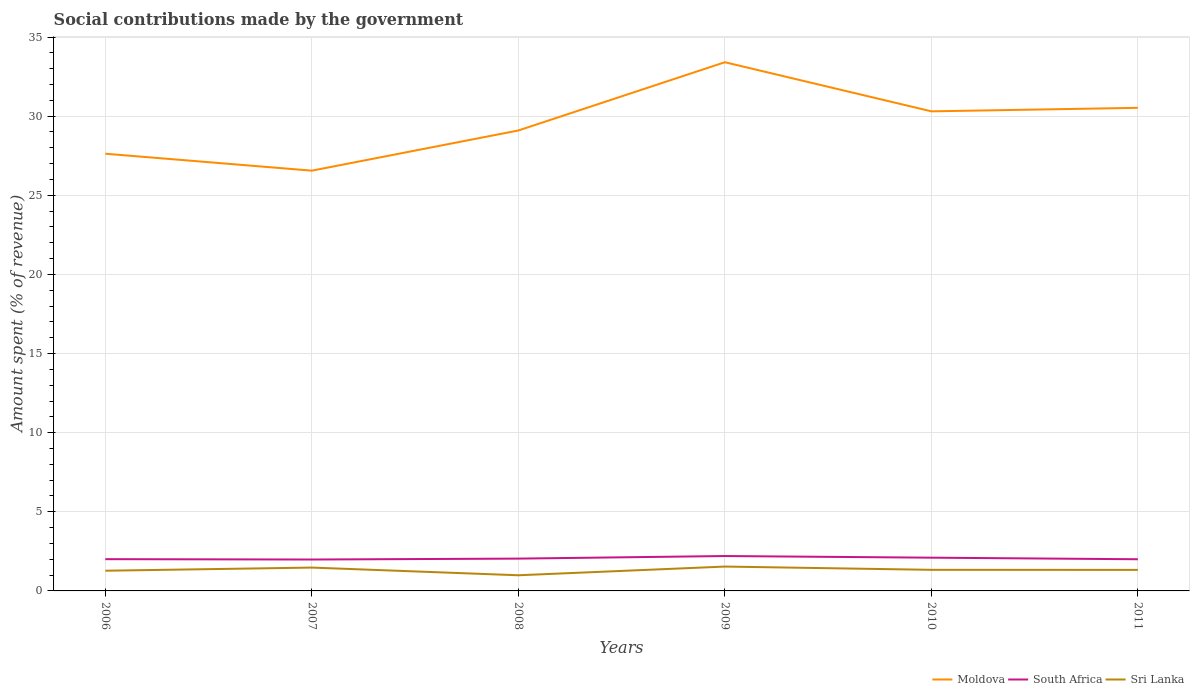Is the number of lines equal to the number of legend labels?
Ensure brevity in your answer.  Yes. Across all years, what is the maximum amount spent (in %) on social contributions in Moldova?
Give a very brief answer. 26.56. In which year was the amount spent (in %) on social contributions in Moldova maximum?
Provide a short and direct response. 2007. What is the total amount spent (in %) on social contributions in South Africa in the graph?
Offer a terse response. -0.06. What is the difference between the highest and the second highest amount spent (in %) on social contributions in Sri Lanka?
Give a very brief answer. 0.55. Is the amount spent (in %) on social contributions in Moldova strictly greater than the amount spent (in %) on social contributions in Sri Lanka over the years?
Provide a short and direct response. No. How many lines are there?
Provide a short and direct response. 3. Does the graph contain grids?
Your response must be concise. Yes. Where does the legend appear in the graph?
Offer a very short reply. Bottom right. How many legend labels are there?
Keep it short and to the point. 3. What is the title of the graph?
Provide a short and direct response. Social contributions made by the government. Does "Myanmar" appear as one of the legend labels in the graph?
Ensure brevity in your answer.  No. What is the label or title of the X-axis?
Your response must be concise. Years. What is the label or title of the Y-axis?
Offer a very short reply. Amount spent (% of revenue). What is the Amount spent (% of revenue) of Moldova in 2006?
Ensure brevity in your answer.  27.63. What is the Amount spent (% of revenue) of South Africa in 2006?
Your response must be concise. 2.01. What is the Amount spent (% of revenue) of Sri Lanka in 2006?
Offer a very short reply. 1.28. What is the Amount spent (% of revenue) in Moldova in 2007?
Your answer should be very brief. 26.56. What is the Amount spent (% of revenue) of South Africa in 2007?
Make the answer very short. 1.98. What is the Amount spent (% of revenue) in Sri Lanka in 2007?
Your response must be concise. 1.48. What is the Amount spent (% of revenue) of Moldova in 2008?
Offer a terse response. 29.1. What is the Amount spent (% of revenue) in South Africa in 2008?
Your answer should be very brief. 2.04. What is the Amount spent (% of revenue) of Sri Lanka in 2008?
Offer a very short reply. 0.99. What is the Amount spent (% of revenue) of Moldova in 2009?
Your response must be concise. 33.41. What is the Amount spent (% of revenue) of South Africa in 2009?
Your answer should be compact. 2.2. What is the Amount spent (% of revenue) of Sri Lanka in 2009?
Provide a short and direct response. 1.54. What is the Amount spent (% of revenue) of Moldova in 2010?
Your response must be concise. 30.31. What is the Amount spent (% of revenue) in South Africa in 2010?
Offer a terse response. 2.1. What is the Amount spent (% of revenue) in Sri Lanka in 2010?
Your answer should be compact. 1.33. What is the Amount spent (% of revenue) in Moldova in 2011?
Ensure brevity in your answer.  30.53. What is the Amount spent (% of revenue) in South Africa in 2011?
Provide a succinct answer. 2. What is the Amount spent (% of revenue) in Sri Lanka in 2011?
Offer a terse response. 1.33. Across all years, what is the maximum Amount spent (% of revenue) in Moldova?
Keep it short and to the point. 33.41. Across all years, what is the maximum Amount spent (% of revenue) of South Africa?
Your answer should be compact. 2.2. Across all years, what is the maximum Amount spent (% of revenue) in Sri Lanka?
Keep it short and to the point. 1.54. Across all years, what is the minimum Amount spent (% of revenue) of Moldova?
Your response must be concise. 26.56. Across all years, what is the minimum Amount spent (% of revenue) of South Africa?
Ensure brevity in your answer.  1.98. Across all years, what is the minimum Amount spent (% of revenue) in Sri Lanka?
Provide a succinct answer. 0.99. What is the total Amount spent (% of revenue) of Moldova in the graph?
Give a very brief answer. 177.52. What is the total Amount spent (% of revenue) in South Africa in the graph?
Give a very brief answer. 12.34. What is the total Amount spent (% of revenue) of Sri Lanka in the graph?
Provide a short and direct response. 7.94. What is the difference between the Amount spent (% of revenue) in Moldova in 2006 and that in 2007?
Your answer should be very brief. 1.07. What is the difference between the Amount spent (% of revenue) in South Africa in 2006 and that in 2007?
Your answer should be very brief. 0.02. What is the difference between the Amount spent (% of revenue) of Sri Lanka in 2006 and that in 2007?
Provide a short and direct response. -0.2. What is the difference between the Amount spent (% of revenue) of Moldova in 2006 and that in 2008?
Offer a very short reply. -1.47. What is the difference between the Amount spent (% of revenue) in South Africa in 2006 and that in 2008?
Offer a very short reply. -0.03. What is the difference between the Amount spent (% of revenue) of Sri Lanka in 2006 and that in 2008?
Your response must be concise. 0.29. What is the difference between the Amount spent (% of revenue) in Moldova in 2006 and that in 2009?
Offer a terse response. -5.78. What is the difference between the Amount spent (% of revenue) in South Africa in 2006 and that in 2009?
Ensure brevity in your answer.  -0.2. What is the difference between the Amount spent (% of revenue) in Sri Lanka in 2006 and that in 2009?
Offer a terse response. -0.26. What is the difference between the Amount spent (% of revenue) of Moldova in 2006 and that in 2010?
Your response must be concise. -2.68. What is the difference between the Amount spent (% of revenue) in South Africa in 2006 and that in 2010?
Give a very brief answer. -0.09. What is the difference between the Amount spent (% of revenue) in Sri Lanka in 2006 and that in 2010?
Offer a very short reply. -0.06. What is the difference between the Amount spent (% of revenue) of Moldova in 2006 and that in 2011?
Offer a very short reply. -2.9. What is the difference between the Amount spent (% of revenue) of South Africa in 2006 and that in 2011?
Your response must be concise. 0.01. What is the difference between the Amount spent (% of revenue) of Sri Lanka in 2006 and that in 2011?
Provide a succinct answer. -0.05. What is the difference between the Amount spent (% of revenue) of Moldova in 2007 and that in 2008?
Give a very brief answer. -2.54. What is the difference between the Amount spent (% of revenue) in South Africa in 2007 and that in 2008?
Ensure brevity in your answer.  -0.06. What is the difference between the Amount spent (% of revenue) in Sri Lanka in 2007 and that in 2008?
Provide a succinct answer. 0.49. What is the difference between the Amount spent (% of revenue) in Moldova in 2007 and that in 2009?
Provide a short and direct response. -6.85. What is the difference between the Amount spent (% of revenue) of South Africa in 2007 and that in 2009?
Offer a terse response. -0.22. What is the difference between the Amount spent (% of revenue) of Sri Lanka in 2007 and that in 2009?
Give a very brief answer. -0.06. What is the difference between the Amount spent (% of revenue) in Moldova in 2007 and that in 2010?
Give a very brief answer. -3.75. What is the difference between the Amount spent (% of revenue) in South Africa in 2007 and that in 2010?
Your answer should be compact. -0.12. What is the difference between the Amount spent (% of revenue) of Sri Lanka in 2007 and that in 2010?
Provide a succinct answer. 0.14. What is the difference between the Amount spent (% of revenue) of Moldova in 2007 and that in 2011?
Make the answer very short. -3.97. What is the difference between the Amount spent (% of revenue) of South Africa in 2007 and that in 2011?
Your response must be concise. -0.02. What is the difference between the Amount spent (% of revenue) of Sri Lanka in 2007 and that in 2011?
Offer a very short reply. 0.15. What is the difference between the Amount spent (% of revenue) in Moldova in 2008 and that in 2009?
Your answer should be very brief. -4.31. What is the difference between the Amount spent (% of revenue) in South Africa in 2008 and that in 2009?
Your response must be concise. -0.16. What is the difference between the Amount spent (% of revenue) in Sri Lanka in 2008 and that in 2009?
Make the answer very short. -0.55. What is the difference between the Amount spent (% of revenue) in Moldova in 2008 and that in 2010?
Your answer should be very brief. -1.21. What is the difference between the Amount spent (% of revenue) in South Africa in 2008 and that in 2010?
Your answer should be compact. -0.06. What is the difference between the Amount spent (% of revenue) in Sri Lanka in 2008 and that in 2010?
Your response must be concise. -0.34. What is the difference between the Amount spent (% of revenue) of Moldova in 2008 and that in 2011?
Provide a short and direct response. -1.43. What is the difference between the Amount spent (% of revenue) of South Africa in 2008 and that in 2011?
Your response must be concise. 0.04. What is the difference between the Amount spent (% of revenue) of Sri Lanka in 2008 and that in 2011?
Offer a terse response. -0.34. What is the difference between the Amount spent (% of revenue) of Moldova in 2009 and that in 2010?
Offer a terse response. 3.1. What is the difference between the Amount spent (% of revenue) of South Africa in 2009 and that in 2010?
Provide a short and direct response. 0.1. What is the difference between the Amount spent (% of revenue) of Sri Lanka in 2009 and that in 2010?
Provide a short and direct response. 0.21. What is the difference between the Amount spent (% of revenue) in Moldova in 2009 and that in 2011?
Your answer should be compact. 2.88. What is the difference between the Amount spent (% of revenue) of South Africa in 2009 and that in 2011?
Give a very brief answer. 0.2. What is the difference between the Amount spent (% of revenue) in Sri Lanka in 2009 and that in 2011?
Offer a terse response. 0.21. What is the difference between the Amount spent (% of revenue) of Moldova in 2010 and that in 2011?
Make the answer very short. -0.22. What is the difference between the Amount spent (% of revenue) of South Africa in 2010 and that in 2011?
Offer a very short reply. 0.1. What is the difference between the Amount spent (% of revenue) of Sri Lanka in 2010 and that in 2011?
Provide a short and direct response. 0. What is the difference between the Amount spent (% of revenue) of Moldova in 2006 and the Amount spent (% of revenue) of South Africa in 2007?
Give a very brief answer. 25.64. What is the difference between the Amount spent (% of revenue) of Moldova in 2006 and the Amount spent (% of revenue) of Sri Lanka in 2007?
Offer a very short reply. 26.15. What is the difference between the Amount spent (% of revenue) in South Africa in 2006 and the Amount spent (% of revenue) in Sri Lanka in 2007?
Your response must be concise. 0.53. What is the difference between the Amount spent (% of revenue) of Moldova in 2006 and the Amount spent (% of revenue) of South Africa in 2008?
Your answer should be compact. 25.59. What is the difference between the Amount spent (% of revenue) in Moldova in 2006 and the Amount spent (% of revenue) in Sri Lanka in 2008?
Offer a very short reply. 26.64. What is the difference between the Amount spent (% of revenue) of South Africa in 2006 and the Amount spent (% of revenue) of Sri Lanka in 2008?
Give a very brief answer. 1.02. What is the difference between the Amount spent (% of revenue) in Moldova in 2006 and the Amount spent (% of revenue) in South Africa in 2009?
Your response must be concise. 25.42. What is the difference between the Amount spent (% of revenue) of Moldova in 2006 and the Amount spent (% of revenue) of Sri Lanka in 2009?
Your response must be concise. 26.09. What is the difference between the Amount spent (% of revenue) in South Africa in 2006 and the Amount spent (% of revenue) in Sri Lanka in 2009?
Provide a succinct answer. 0.47. What is the difference between the Amount spent (% of revenue) of Moldova in 2006 and the Amount spent (% of revenue) of South Africa in 2010?
Make the answer very short. 25.53. What is the difference between the Amount spent (% of revenue) of Moldova in 2006 and the Amount spent (% of revenue) of Sri Lanka in 2010?
Your answer should be compact. 26.29. What is the difference between the Amount spent (% of revenue) in South Africa in 2006 and the Amount spent (% of revenue) in Sri Lanka in 2010?
Offer a very short reply. 0.67. What is the difference between the Amount spent (% of revenue) in Moldova in 2006 and the Amount spent (% of revenue) in South Africa in 2011?
Your response must be concise. 25.63. What is the difference between the Amount spent (% of revenue) in Moldova in 2006 and the Amount spent (% of revenue) in Sri Lanka in 2011?
Your response must be concise. 26.3. What is the difference between the Amount spent (% of revenue) of South Africa in 2006 and the Amount spent (% of revenue) of Sri Lanka in 2011?
Make the answer very short. 0.68. What is the difference between the Amount spent (% of revenue) in Moldova in 2007 and the Amount spent (% of revenue) in South Africa in 2008?
Your answer should be compact. 24.52. What is the difference between the Amount spent (% of revenue) in Moldova in 2007 and the Amount spent (% of revenue) in Sri Lanka in 2008?
Offer a very short reply. 25.57. What is the difference between the Amount spent (% of revenue) of Moldova in 2007 and the Amount spent (% of revenue) of South Africa in 2009?
Your answer should be compact. 24.35. What is the difference between the Amount spent (% of revenue) in Moldova in 2007 and the Amount spent (% of revenue) in Sri Lanka in 2009?
Your answer should be very brief. 25.02. What is the difference between the Amount spent (% of revenue) of South Africa in 2007 and the Amount spent (% of revenue) of Sri Lanka in 2009?
Your answer should be very brief. 0.45. What is the difference between the Amount spent (% of revenue) of Moldova in 2007 and the Amount spent (% of revenue) of South Africa in 2010?
Your answer should be compact. 24.46. What is the difference between the Amount spent (% of revenue) in Moldova in 2007 and the Amount spent (% of revenue) in Sri Lanka in 2010?
Your response must be concise. 25.22. What is the difference between the Amount spent (% of revenue) in South Africa in 2007 and the Amount spent (% of revenue) in Sri Lanka in 2010?
Provide a short and direct response. 0.65. What is the difference between the Amount spent (% of revenue) of Moldova in 2007 and the Amount spent (% of revenue) of South Africa in 2011?
Ensure brevity in your answer.  24.56. What is the difference between the Amount spent (% of revenue) of Moldova in 2007 and the Amount spent (% of revenue) of Sri Lanka in 2011?
Give a very brief answer. 25.23. What is the difference between the Amount spent (% of revenue) in South Africa in 2007 and the Amount spent (% of revenue) in Sri Lanka in 2011?
Make the answer very short. 0.66. What is the difference between the Amount spent (% of revenue) of Moldova in 2008 and the Amount spent (% of revenue) of South Africa in 2009?
Give a very brief answer. 26.89. What is the difference between the Amount spent (% of revenue) of Moldova in 2008 and the Amount spent (% of revenue) of Sri Lanka in 2009?
Make the answer very short. 27.56. What is the difference between the Amount spent (% of revenue) in South Africa in 2008 and the Amount spent (% of revenue) in Sri Lanka in 2009?
Your answer should be compact. 0.5. What is the difference between the Amount spent (% of revenue) of Moldova in 2008 and the Amount spent (% of revenue) of South Africa in 2010?
Your answer should be compact. 26.99. What is the difference between the Amount spent (% of revenue) in Moldova in 2008 and the Amount spent (% of revenue) in Sri Lanka in 2010?
Provide a short and direct response. 27.76. What is the difference between the Amount spent (% of revenue) in South Africa in 2008 and the Amount spent (% of revenue) in Sri Lanka in 2010?
Provide a short and direct response. 0.71. What is the difference between the Amount spent (% of revenue) of Moldova in 2008 and the Amount spent (% of revenue) of South Africa in 2011?
Offer a terse response. 27.09. What is the difference between the Amount spent (% of revenue) in Moldova in 2008 and the Amount spent (% of revenue) in Sri Lanka in 2011?
Keep it short and to the point. 27.77. What is the difference between the Amount spent (% of revenue) in South Africa in 2008 and the Amount spent (% of revenue) in Sri Lanka in 2011?
Keep it short and to the point. 0.71. What is the difference between the Amount spent (% of revenue) in Moldova in 2009 and the Amount spent (% of revenue) in South Africa in 2010?
Make the answer very short. 31.31. What is the difference between the Amount spent (% of revenue) in Moldova in 2009 and the Amount spent (% of revenue) in Sri Lanka in 2010?
Offer a very short reply. 32.08. What is the difference between the Amount spent (% of revenue) in South Africa in 2009 and the Amount spent (% of revenue) in Sri Lanka in 2010?
Give a very brief answer. 0.87. What is the difference between the Amount spent (% of revenue) of Moldova in 2009 and the Amount spent (% of revenue) of South Africa in 2011?
Offer a very short reply. 31.41. What is the difference between the Amount spent (% of revenue) in Moldova in 2009 and the Amount spent (% of revenue) in Sri Lanka in 2011?
Offer a terse response. 32.08. What is the difference between the Amount spent (% of revenue) in South Africa in 2009 and the Amount spent (% of revenue) in Sri Lanka in 2011?
Your answer should be very brief. 0.88. What is the difference between the Amount spent (% of revenue) in Moldova in 2010 and the Amount spent (% of revenue) in South Africa in 2011?
Your response must be concise. 28.3. What is the difference between the Amount spent (% of revenue) of Moldova in 2010 and the Amount spent (% of revenue) of Sri Lanka in 2011?
Offer a very short reply. 28.98. What is the difference between the Amount spent (% of revenue) in South Africa in 2010 and the Amount spent (% of revenue) in Sri Lanka in 2011?
Keep it short and to the point. 0.77. What is the average Amount spent (% of revenue) of Moldova per year?
Keep it short and to the point. 29.59. What is the average Amount spent (% of revenue) of South Africa per year?
Make the answer very short. 2.06. What is the average Amount spent (% of revenue) of Sri Lanka per year?
Ensure brevity in your answer.  1.32. In the year 2006, what is the difference between the Amount spent (% of revenue) in Moldova and Amount spent (% of revenue) in South Africa?
Give a very brief answer. 25.62. In the year 2006, what is the difference between the Amount spent (% of revenue) of Moldova and Amount spent (% of revenue) of Sri Lanka?
Keep it short and to the point. 26.35. In the year 2006, what is the difference between the Amount spent (% of revenue) of South Africa and Amount spent (% of revenue) of Sri Lanka?
Your response must be concise. 0.73. In the year 2007, what is the difference between the Amount spent (% of revenue) of Moldova and Amount spent (% of revenue) of South Africa?
Your response must be concise. 24.57. In the year 2007, what is the difference between the Amount spent (% of revenue) of Moldova and Amount spent (% of revenue) of Sri Lanka?
Give a very brief answer. 25.08. In the year 2007, what is the difference between the Amount spent (% of revenue) in South Africa and Amount spent (% of revenue) in Sri Lanka?
Your answer should be very brief. 0.51. In the year 2008, what is the difference between the Amount spent (% of revenue) of Moldova and Amount spent (% of revenue) of South Africa?
Provide a succinct answer. 27.05. In the year 2008, what is the difference between the Amount spent (% of revenue) of Moldova and Amount spent (% of revenue) of Sri Lanka?
Your response must be concise. 28.11. In the year 2008, what is the difference between the Amount spent (% of revenue) of South Africa and Amount spent (% of revenue) of Sri Lanka?
Your answer should be very brief. 1.05. In the year 2009, what is the difference between the Amount spent (% of revenue) of Moldova and Amount spent (% of revenue) of South Africa?
Make the answer very short. 31.2. In the year 2009, what is the difference between the Amount spent (% of revenue) in Moldova and Amount spent (% of revenue) in Sri Lanka?
Your answer should be very brief. 31.87. In the year 2009, what is the difference between the Amount spent (% of revenue) of South Africa and Amount spent (% of revenue) of Sri Lanka?
Your answer should be compact. 0.67. In the year 2010, what is the difference between the Amount spent (% of revenue) of Moldova and Amount spent (% of revenue) of South Africa?
Ensure brevity in your answer.  28.2. In the year 2010, what is the difference between the Amount spent (% of revenue) in Moldova and Amount spent (% of revenue) in Sri Lanka?
Provide a short and direct response. 28.97. In the year 2010, what is the difference between the Amount spent (% of revenue) in South Africa and Amount spent (% of revenue) in Sri Lanka?
Your response must be concise. 0.77. In the year 2011, what is the difference between the Amount spent (% of revenue) in Moldova and Amount spent (% of revenue) in South Africa?
Give a very brief answer. 28.53. In the year 2011, what is the difference between the Amount spent (% of revenue) of Moldova and Amount spent (% of revenue) of Sri Lanka?
Keep it short and to the point. 29.2. In the year 2011, what is the difference between the Amount spent (% of revenue) in South Africa and Amount spent (% of revenue) in Sri Lanka?
Your answer should be very brief. 0.67. What is the ratio of the Amount spent (% of revenue) of Moldova in 2006 to that in 2007?
Your answer should be very brief. 1.04. What is the ratio of the Amount spent (% of revenue) in South Africa in 2006 to that in 2007?
Your response must be concise. 1.01. What is the ratio of the Amount spent (% of revenue) of Sri Lanka in 2006 to that in 2007?
Your answer should be very brief. 0.87. What is the ratio of the Amount spent (% of revenue) of Moldova in 2006 to that in 2008?
Your answer should be very brief. 0.95. What is the ratio of the Amount spent (% of revenue) in South Africa in 2006 to that in 2008?
Offer a very short reply. 0.98. What is the ratio of the Amount spent (% of revenue) of Sri Lanka in 2006 to that in 2008?
Offer a terse response. 1.29. What is the ratio of the Amount spent (% of revenue) of Moldova in 2006 to that in 2009?
Offer a very short reply. 0.83. What is the ratio of the Amount spent (% of revenue) in South Africa in 2006 to that in 2009?
Your response must be concise. 0.91. What is the ratio of the Amount spent (% of revenue) of Sri Lanka in 2006 to that in 2009?
Make the answer very short. 0.83. What is the ratio of the Amount spent (% of revenue) in Moldova in 2006 to that in 2010?
Provide a short and direct response. 0.91. What is the ratio of the Amount spent (% of revenue) of South Africa in 2006 to that in 2010?
Offer a very short reply. 0.96. What is the ratio of the Amount spent (% of revenue) in Sri Lanka in 2006 to that in 2010?
Provide a succinct answer. 0.96. What is the ratio of the Amount spent (% of revenue) of Moldova in 2006 to that in 2011?
Your response must be concise. 0.91. What is the ratio of the Amount spent (% of revenue) of Sri Lanka in 2006 to that in 2011?
Provide a succinct answer. 0.96. What is the ratio of the Amount spent (% of revenue) of Moldova in 2007 to that in 2008?
Give a very brief answer. 0.91. What is the ratio of the Amount spent (% of revenue) in South Africa in 2007 to that in 2008?
Offer a terse response. 0.97. What is the ratio of the Amount spent (% of revenue) of Sri Lanka in 2007 to that in 2008?
Your answer should be compact. 1.49. What is the ratio of the Amount spent (% of revenue) in Moldova in 2007 to that in 2009?
Your answer should be very brief. 0.79. What is the ratio of the Amount spent (% of revenue) of South Africa in 2007 to that in 2009?
Give a very brief answer. 0.9. What is the ratio of the Amount spent (% of revenue) of Sri Lanka in 2007 to that in 2009?
Provide a succinct answer. 0.96. What is the ratio of the Amount spent (% of revenue) in Moldova in 2007 to that in 2010?
Your answer should be compact. 0.88. What is the ratio of the Amount spent (% of revenue) in South Africa in 2007 to that in 2010?
Offer a terse response. 0.94. What is the ratio of the Amount spent (% of revenue) of Sri Lanka in 2007 to that in 2010?
Provide a short and direct response. 1.11. What is the ratio of the Amount spent (% of revenue) in Moldova in 2007 to that in 2011?
Offer a terse response. 0.87. What is the ratio of the Amount spent (% of revenue) in South Africa in 2007 to that in 2011?
Ensure brevity in your answer.  0.99. What is the ratio of the Amount spent (% of revenue) in Sri Lanka in 2007 to that in 2011?
Offer a very short reply. 1.11. What is the ratio of the Amount spent (% of revenue) in Moldova in 2008 to that in 2009?
Give a very brief answer. 0.87. What is the ratio of the Amount spent (% of revenue) of South Africa in 2008 to that in 2009?
Give a very brief answer. 0.93. What is the ratio of the Amount spent (% of revenue) in Sri Lanka in 2008 to that in 2009?
Your answer should be compact. 0.64. What is the ratio of the Amount spent (% of revenue) of Moldova in 2008 to that in 2010?
Provide a succinct answer. 0.96. What is the ratio of the Amount spent (% of revenue) in South Africa in 2008 to that in 2010?
Offer a terse response. 0.97. What is the ratio of the Amount spent (% of revenue) of Sri Lanka in 2008 to that in 2010?
Keep it short and to the point. 0.74. What is the ratio of the Amount spent (% of revenue) in Moldova in 2008 to that in 2011?
Make the answer very short. 0.95. What is the ratio of the Amount spent (% of revenue) in South Africa in 2008 to that in 2011?
Offer a very short reply. 1.02. What is the ratio of the Amount spent (% of revenue) in Sri Lanka in 2008 to that in 2011?
Give a very brief answer. 0.74. What is the ratio of the Amount spent (% of revenue) of Moldova in 2009 to that in 2010?
Make the answer very short. 1.1. What is the ratio of the Amount spent (% of revenue) in South Africa in 2009 to that in 2010?
Your response must be concise. 1.05. What is the ratio of the Amount spent (% of revenue) of Sri Lanka in 2009 to that in 2010?
Provide a succinct answer. 1.15. What is the ratio of the Amount spent (% of revenue) in Moldova in 2009 to that in 2011?
Ensure brevity in your answer.  1.09. What is the ratio of the Amount spent (% of revenue) of South Africa in 2009 to that in 2011?
Offer a terse response. 1.1. What is the ratio of the Amount spent (% of revenue) in Sri Lanka in 2009 to that in 2011?
Offer a very short reply. 1.16. What is the ratio of the Amount spent (% of revenue) of South Africa in 2010 to that in 2011?
Your answer should be compact. 1.05. What is the ratio of the Amount spent (% of revenue) of Sri Lanka in 2010 to that in 2011?
Keep it short and to the point. 1. What is the difference between the highest and the second highest Amount spent (% of revenue) of Moldova?
Make the answer very short. 2.88. What is the difference between the highest and the second highest Amount spent (% of revenue) of South Africa?
Offer a terse response. 0.1. What is the difference between the highest and the second highest Amount spent (% of revenue) of Sri Lanka?
Your answer should be compact. 0.06. What is the difference between the highest and the lowest Amount spent (% of revenue) in Moldova?
Offer a very short reply. 6.85. What is the difference between the highest and the lowest Amount spent (% of revenue) of South Africa?
Your answer should be very brief. 0.22. What is the difference between the highest and the lowest Amount spent (% of revenue) in Sri Lanka?
Keep it short and to the point. 0.55. 